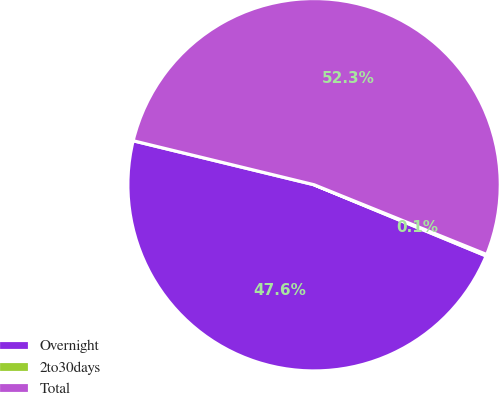Convert chart to OTSL. <chart><loc_0><loc_0><loc_500><loc_500><pie_chart><fcel>Overnight<fcel>2to30days<fcel>Total<nl><fcel>47.55%<fcel>0.13%<fcel>52.31%<nl></chart> 